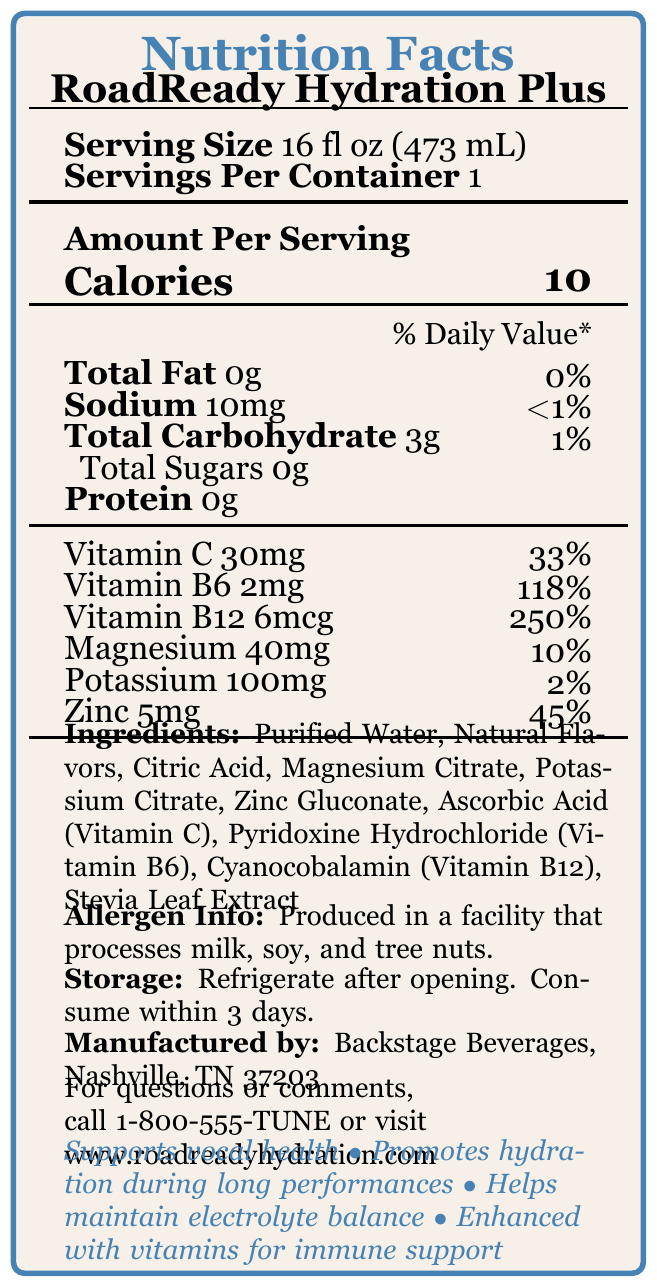what is the serving size of RoadReady Hydration Plus? The serving size is specified near the top of the document under the product name and serving details.
Answer: 16 fl oz (473 mL) how many servings per container are there for RoadReady Hydration Plus? The document indicates "Servings Per Container" as 1.
Answer: 1 how many calories are in one serving of RoadReady Hydration Plus? The calorie count is shown prominently in the "Amount Per Serving" section at the top.
Answer: 10 how much vitamin C does one serving contain? The amount of vitamin C is listed in the vitamins section, and it's 30mg per serving.
Answer: 30mg what percent of the daily value of Vitamin B12 does a single serving provide? The daily value percentage for Vitamin B12 is given as 250%.
Answer: 250% what are the ingredients in RoadReady Hydration Plus? The ingredients are listed towards the bottom of the document.
Answer: Purified Water, Natural Flavors, Citric Acid, Magnesium Citrate, Potassium Citrate, Zinc Gluconate, Ascorbic Acid (Vitamin C), Pyridoxine Hydrochloride (Vitamin B6), Cyanocobalamin (Vitamin B12), Stevia Leaf Extract is RoadReady Hydration Plus recommended for vocal health? The claims section states "Supports vocal health" among other benefits.
Answer: Yes what should you do after opening the bottle of RoadReady Hydration Plus? A. Freeze it B. Leave it out C. Refrigerate it D. Discard it The storage instructions clearly state to refrigerate after opening.
Answer: C. Refrigerate it how much zinc is in each serving of RoadReady Hydration Plus? A. 2mg B. 5mg C. 10mg D. 20mg The amount of zinc per serving is listed as 5mg.
Answer: B. 5mg does RoadReady Hydration Plus contain any sodium? The sodium content is given as 10mg.
Answer: Yes what claims does RoadReady Hydration Plus make about its benefits? These claims are listed in the claims section at the bottom of the document.
Answer: Supports vocal health, Promotes hydration during long performances, Helps maintain electrolyte balance, Enhanced with vitamins for immune support how much protein is in RoadReady Hydration Plus? The amount of protein is indicated as 0g in the nutritional information.
Answer: 0g where is RoadReady Hydration Plus manufactured? The manufacturer information is listed at the bottom of the document.
Answer: Backstage Beverages, Nashville, TN 37203 who should be contacted for questions or comments about RoadReady Hydration Plus? The contact information is provided at the bottom of the document.
Answer: 1-800-555-TUNE or visit www.roadreadyhydration.com is the daily value percentage for potassium higher than that for magnesium? Potassium's daily value is 2% while magnesium's is 10%.
Answer: No is RoadReady Hydration Plus safe for someone with a milk allergy? The document states it's produced in a facility that processes milk, soy, and tree nuts, but does not specify whether the product itself is free from these allergens.
Answer: Cannot be determined summarize the main nutritional benefits of RoadReady Hydration Plus. The summary covers the main points detailed in the nutritional information, claims, and ingredients sections of the document.
Answer: RoadReady Hydration Plus is a low-calorie, vitamin-fortified bottled water that supports vocal health, promotes hydration, maintains electrolyte balance, and boosts immune support with its enhanced vitamins. 